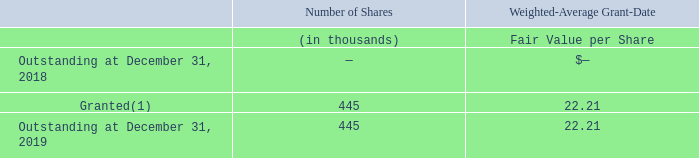Performance-Based Restricted Stock Units
Performance-based restricted stock units are eligible to vest at the end of each fiscal year in a three-year performance period based on the Company’s annual growth rate in net sales and non-GAAP diluted earnings per share (subject to certain adjustments) over a multiple of four times the related results for the fourth quarter of 2018 relative to the growth rates for a peer group of companies for the same metrics and periods.
For the performance-based restricted stock units granted in 2019, 60% of each performance-based award is subject to the net sales metric for the performance period and 40% is subject to the non-GAAP diluted earnings per share metric for the performance period. The maximum percentage for a particular metric is2 50% of the target number of units subject to the award related to that metric, however, vesting of the performance stock units is capped at 30% and 100%, respectively, of the target number of units subject to the award in years one and two, respectively, of the three-year performance period.
As of December 31, 2019, the Company believes that it is probable that the Company will achieve performance metrics specified in the award agreement based on its expected revenue and non-GAAP diluted EPS results over the performance period and calculated growth rates relative to its peers’ expected results based on data available, as defined in the award agreement.
A summary of the Company’s performance-based restricted stock unit activity is as follows:
(1) Number of shares granted is based on the maximum percentage achievable in the performance-based restricted stock unit award.
What is the number of shares Outstanding at December 31, 2019?
Answer scale should be: thousand. 445. What percentage of each performance-based award is subject to the net sales metric for the performance period? 60%. What was the number of shares granted in 2019?
Answer scale should be: thousand. 445. What was the change in the outstanding from 2018 to 2019?
Answer scale should be: thousand. 445 - 0 
Answer: 445. What percentage of outstanding in 2019 was granted shares?
Answer scale should be: percent. 445 / 445
Answer: 100. In which year was outstanding shares less than 200 thousands? Locate and analyze outstanding in rows 3 and 5
answer: 2018. 